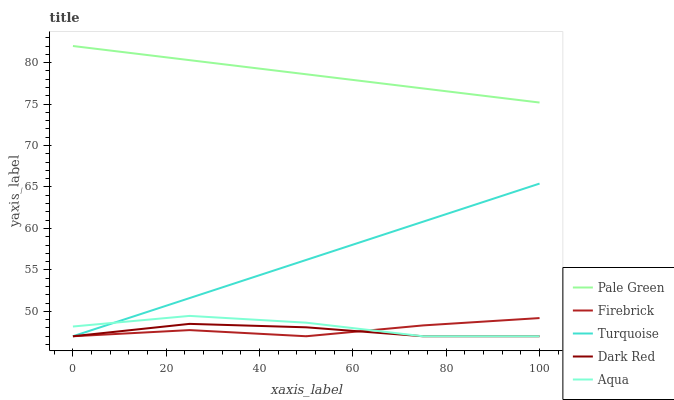Does Dark Red have the minimum area under the curve?
Answer yes or no. Yes. Does Pale Green have the maximum area under the curve?
Answer yes or no. Yes. Does Firebrick have the minimum area under the curve?
Answer yes or no. No. Does Firebrick have the maximum area under the curve?
Answer yes or no. No. Is Pale Green the smoothest?
Answer yes or no. Yes. Is Aqua the roughest?
Answer yes or no. Yes. Is Firebrick the smoothest?
Answer yes or no. No. Is Firebrick the roughest?
Answer yes or no. No. Does Pale Green have the lowest value?
Answer yes or no. No. Does Firebrick have the highest value?
Answer yes or no. No. Is Aqua less than Pale Green?
Answer yes or no. Yes. Is Pale Green greater than Dark Red?
Answer yes or no. Yes. Does Aqua intersect Pale Green?
Answer yes or no. No. 